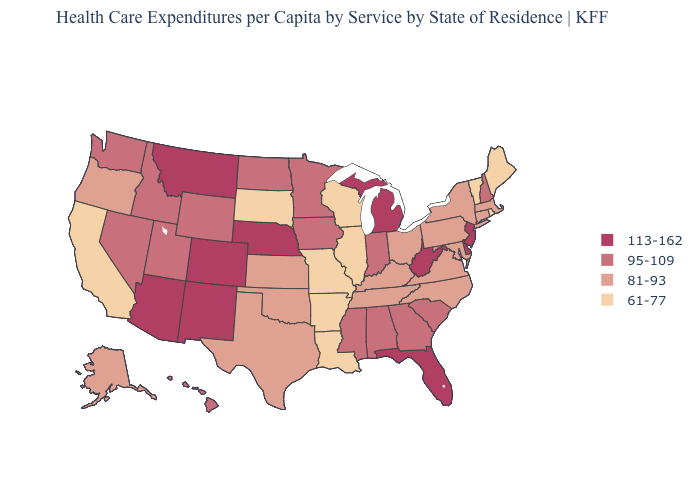Does the map have missing data?
Be succinct. No. What is the value of Pennsylvania?
Be succinct. 81-93. What is the value of South Dakota?
Be succinct. 61-77. Name the states that have a value in the range 61-77?
Answer briefly. Arkansas, California, Illinois, Louisiana, Maine, Missouri, Rhode Island, South Dakota, Vermont, Wisconsin. Among the states that border North Dakota , does Montana have the highest value?
Write a very short answer. Yes. What is the value of Florida?
Keep it brief. 113-162. What is the value of Indiana?
Quick response, please. 95-109. Does Virginia have the highest value in the South?
Quick response, please. No. Does the map have missing data?
Give a very brief answer. No. Name the states that have a value in the range 95-109?
Keep it brief. Alabama, Georgia, Hawaii, Idaho, Indiana, Iowa, Minnesota, Mississippi, Nevada, New Hampshire, North Dakota, South Carolina, Utah, Washington, Wyoming. What is the value of Florida?
Quick response, please. 113-162. Name the states that have a value in the range 95-109?
Be succinct. Alabama, Georgia, Hawaii, Idaho, Indiana, Iowa, Minnesota, Mississippi, Nevada, New Hampshire, North Dakota, South Carolina, Utah, Washington, Wyoming. What is the highest value in states that border North Dakota?
Quick response, please. 113-162. Which states have the lowest value in the West?
Write a very short answer. California. What is the value of Massachusetts?
Be succinct. 81-93. 